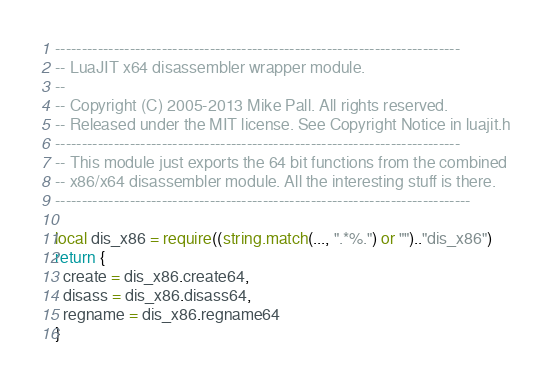<code> <loc_0><loc_0><loc_500><loc_500><_Lua_>----------------------------------------------------------------------------
-- LuaJIT x64 disassembler wrapper module.
--
-- Copyright (C) 2005-2013 Mike Pall. All rights reserved.
-- Released under the MIT license. See Copyright Notice in luajit.h
----------------------------------------------------------------------------
-- This module just exports the 64 bit functions from the combined
-- x86/x64 disassembler module. All the interesting stuff is there.
------------------------------------------------------------------------------

local dis_x86 = require((string.match(..., ".*%.") or "").."dis_x86")
return {
  create = dis_x86.create64,
  disass = dis_x86.disass64,
  regname = dis_x86.regname64
}

</code> 